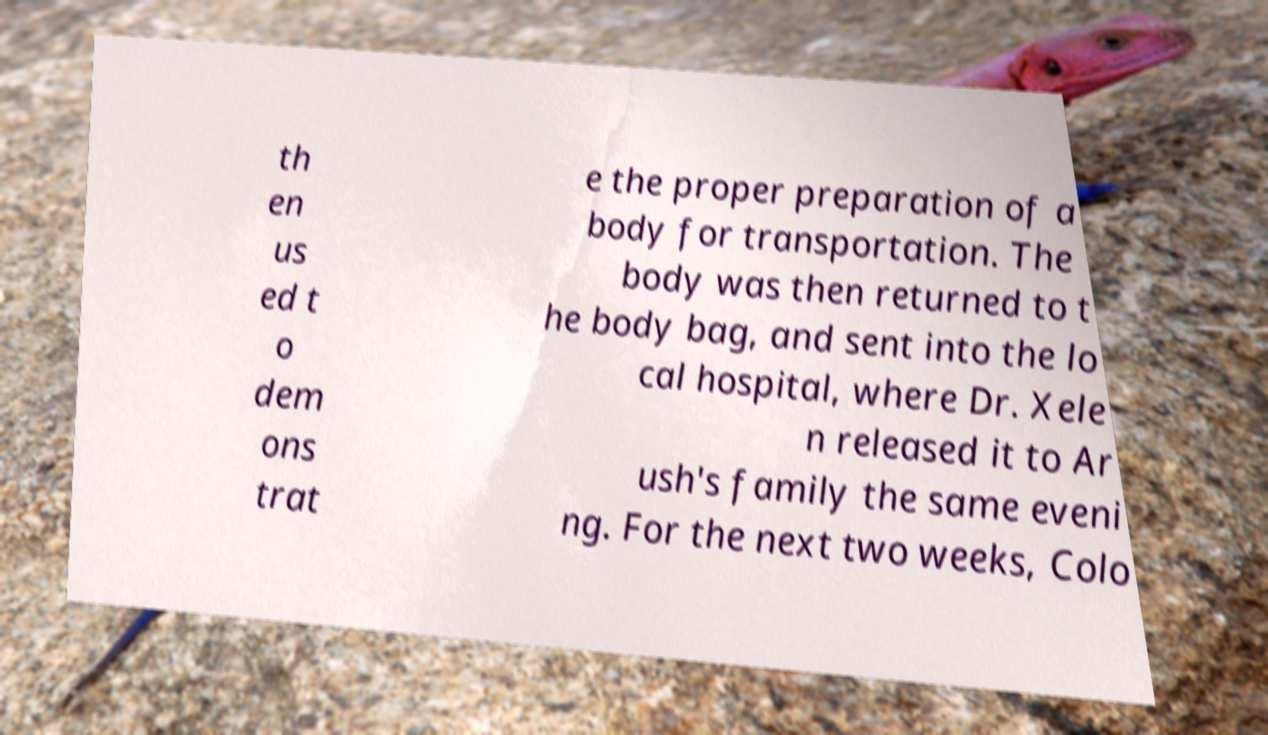Can you accurately transcribe the text from the provided image for me? th en us ed t o dem ons trat e the proper preparation of a body for transportation. The body was then returned to t he body bag, and sent into the lo cal hospital, where Dr. Xele n released it to Ar ush's family the same eveni ng. For the next two weeks, Colo 